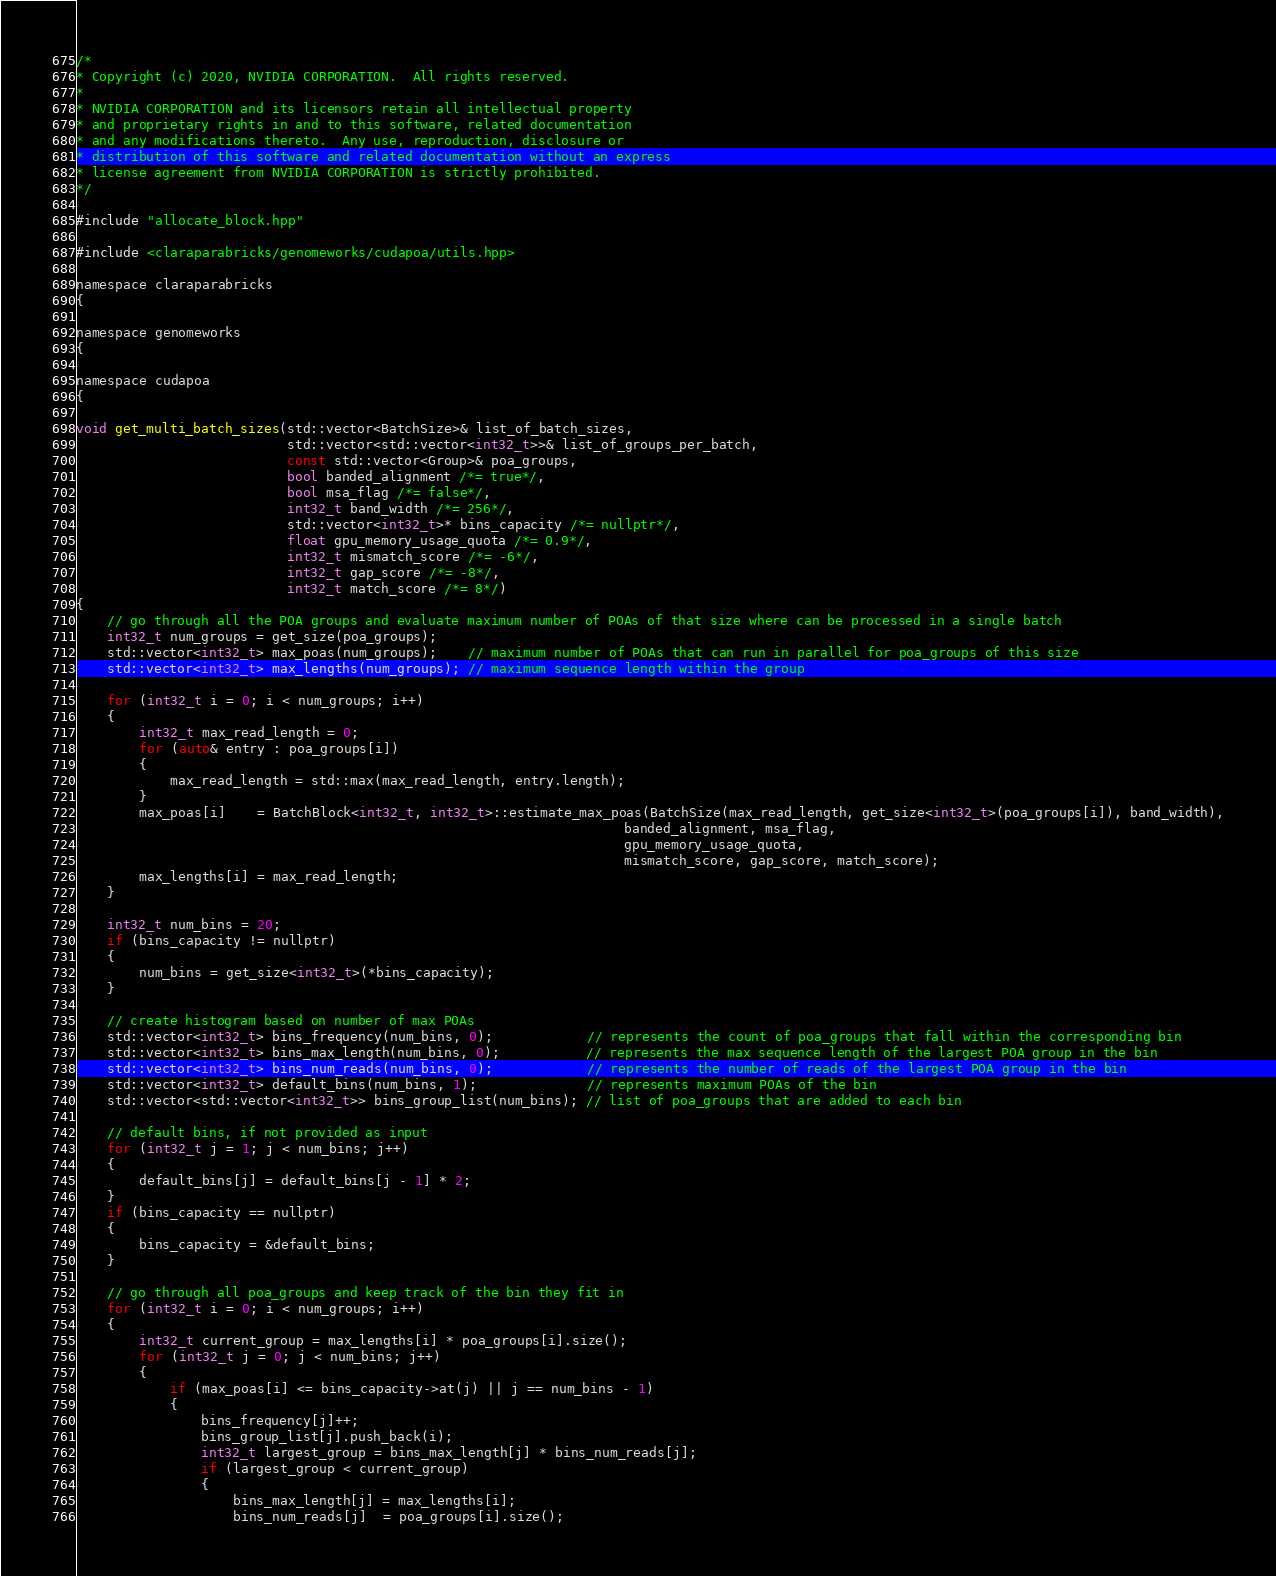<code> <loc_0><loc_0><loc_500><loc_500><_Cuda_>/*
* Copyright (c) 2020, NVIDIA CORPORATION.  All rights reserved.
*
* NVIDIA CORPORATION and its licensors retain all intellectual property
* and proprietary rights in and to this software, related documentation
* and any modifications thereto.  Any use, reproduction, disclosure or
* distribution of this software and related documentation without an express
* license agreement from NVIDIA CORPORATION is strictly prohibited.
*/

#include "allocate_block.hpp"

#include <claraparabricks/genomeworks/cudapoa/utils.hpp>

namespace claraparabricks
{

namespace genomeworks
{

namespace cudapoa
{

void get_multi_batch_sizes(std::vector<BatchSize>& list_of_batch_sizes,
                           std::vector<std::vector<int32_t>>& list_of_groups_per_batch,
                           const std::vector<Group>& poa_groups,
                           bool banded_alignment /*= true*/,
                           bool msa_flag /*= false*/,
                           int32_t band_width /*= 256*/,
                           std::vector<int32_t>* bins_capacity /*= nullptr*/,
                           float gpu_memory_usage_quota /*= 0.9*/,
                           int32_t mismatch_score /*= -6*/,
                           int32_t gap_score /*= -8*/,
                           int32_t match_score /*= 8*/)
{
    // go through all the POA groups and evaluate maximum number of POAs of that size where can be processed in a single batch
    int32_t num_groups = get_size(poa_groups);
    std::vector<int32_t> max_poas(num_groups);    // maximum number of POAs that can run in parallel for poa_groups of this size
    std::vector<int32_t> max_lengths(num_groups); // maximum sequence length within the group

    for (int32_t i = 0; i < num_groups; i++)
    {
        int32_t max_read_length = 0;
        for (auto& entry : poa_groups[i])
        {
            max_read_length = std::max(max_read_length, entry.length);
        }
        max_poas[i]    = BatchBlock<int32_t, int32_t>::estimate_max_poas(BatchSize(max_read_length, get_size<int32_t>(poa_groups[i]), band_width),
                                                                      banded_alignment, msa_flag,
                                                                      gpu_memory_usage_quota,
                                                                      mismatch_score, gap_score, match_score);
        max_lengths[i] = max_read_length;
    }

    int32_t num_bins = 20;
    if (bins_capacity != nullptr)
    {
        num_bins = get_size<int32_t>(*bins_capacity);
    }

    // create histogram based on number of max POAs
    std::vector<int32_t> bins_frequency(num_bins, 0);            // represents the count of poa_groups that fall within the corresponding bin
    std::vector<int32_t> bins_max_length(num_bins, 0);           // represents the max sequence length of the largest POA group in the bin
    std::vector<int32_t> bins_num_reads(num_bins, 0);            // represents the number of reads of the largest POA group in the bin
    std::vector<int32_t> default_bins(num_bins, 1);              // represents maximum POAs of the bin
    std::vector<std::vector<int32_t>> bins_group_list(num_bins); // list of poa_groups that are added to each bin

    // default bins, if not provided as input
    for (int32_t j = 1; j < num_bins; j++)
    {
        default_bins[j] = default_bins[j - 1] * 2;
    }
    if (bins_capacity == nullptr)
    {
        bins_capacity = &default_bins;
    }

    // go through all poa_groups and keep track of the bin they fit in
    for (int32_t i = 0; i < num_groups; i++)
    {
        int32_t current_group = max_lengths[i] * poa_groups[i].size();
        for (int32_t j = 0; j < num_bins; j++)
        {
            if (max_poas[i] <= bins_capacity->at(j) || j == num_bins - 1)
            {
                bins_frequency[j]++;
                bins_group_list[j].push_back(i);
                int32_t largest_group = bins_max_length[j] * bins_num_reads[j];
                if (largest_group < current_group)
                {
                    bins_max_length[j] = max_lengths[i];
                    bins_num_reads[j]  = poa_groups[i].size();</code> 